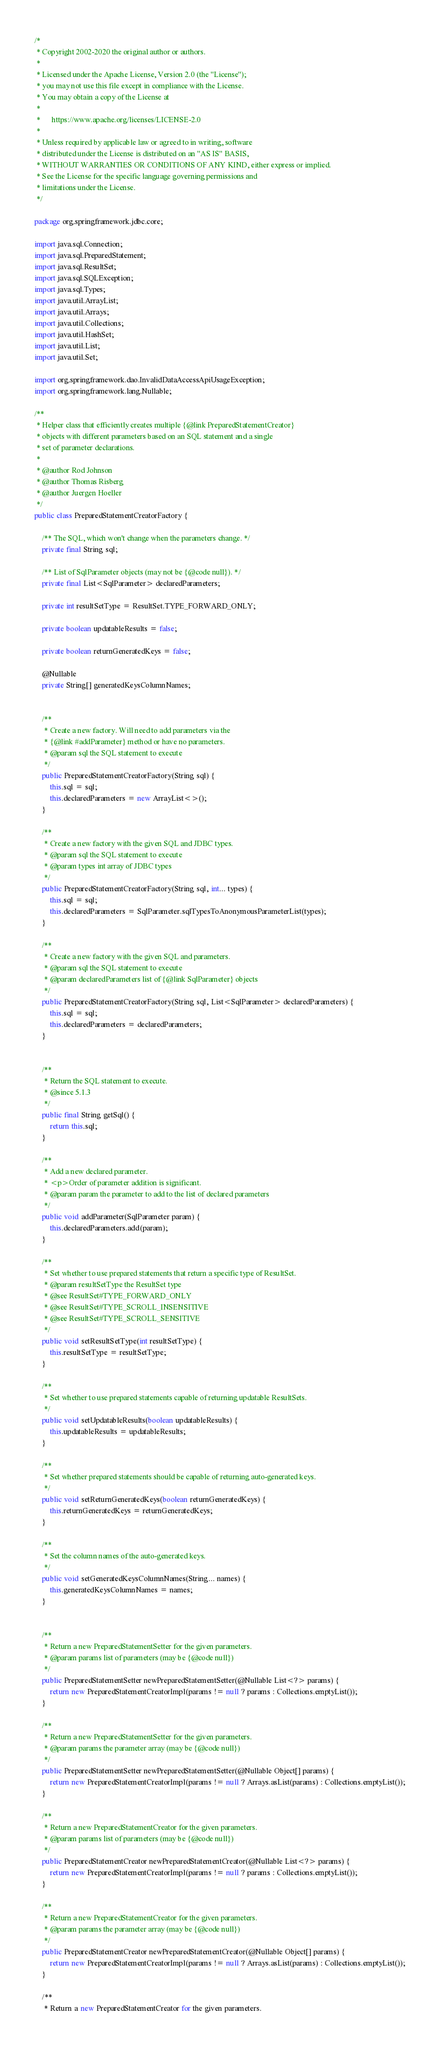Convert code to text. <code><loc_0><loc_0><loc_500><loc_500><_Java_>/*
 * Copyright 2002-2020 the original author or authors.
 *
 * Licensed under the Apache License, Version 2.0 (the "License");
 * you may not use this file except in compliance with the License.
 * You may obtain a copy of the License at
 *
 *      https://www.apache.org/licenses/LICENSE-2.0
 *
 * Unless required by applicable law or agreed to in writing, software
 * distributed under the License is distributed on an "AS IS" BASIS,
 * WITHOUT WARRANTIES OR CONDITIONS OF ANY KIND, either express or implied.
 * See the License for the specific language governing permissions and
 * limitations under the License.
 */

package org.springframework.jdbc.core;

import java.sql.Connection;
import java.sql.PreparedStatement;
import java.sql.ResultSet;
import java.sql.SQLException;
import java.sql.Types;
import java.util.ArrayList;
import java.util.Arrays;
import java.util.Collections;
import java.util.HashSet;
import java.util.List;
import java.util.Set;

import org.springframework.dao.InvalidDataAccessApiUsageException;
import org.springframework.lang.Nullable;

/**
 * Helper class that efficiently creates multiple {@link PreparedStatementCreator}
 * objects with different parameters based on an SQL statement and a single
 * set of parameter declarations.
 *
 * @author Rod Johnson
 * @author Thomas Risberg
 * @author Juergen Hoeller
 */
public class PreparedStatementCreatorFactory {

	/** The SQL, which won't change when the parameters change. */
	private final String sql;

	/** List of SqlParameter objects (may not be {@code null}). */
	private final List<SqlParameter> declaredParameters;

	private int resultSetType = ResultSet.TYPE_FORWARD_ONLY;

	private boolean updatableResults = false;

	private boolean returnGeneratedKeys = false;

	@Nullable
	private String[] generatedKeysColumnNames;


	/**
	 * Create a new factory. Will need to add parameters via the
	 * {@link #addParameter} method or have no parameters.
	 * @param sql the SQL statement to execute
	 */
	public PreparedStatementCreatorFactory(String sql) {
		this.sql = sql;
		this.declaredParameters = new ArrayList<>();
	}

	/**
	 * Create a new factory with the given SQL and JDBC types.
	 * @param sql the SQL statement to execute
	 * @param types int array of JDBC types
	 */
	public PreparedStatementCreatorFactory(String sql, int... types) {
		this.sql = sql;
		this.declaredParameters = SqlParameter.sqlTypesToAnonymousParameterList(types);
	}

	/**
	 * Create a new factory with the given SQL and parameters.
	 * @param sql the SQL statement to execute
	 * @param declaredParameters list of {@link SqlParameter} objects
	 */
	public PreparedStatementCreatorFactory(String sql, List<SqlParameter> declaredParameters) {
		this.sql = sql;
		this.declaredParameters = declaredParameters;
	}


	/**
	 * Return the SQL statement to execute.
	 * @since 5.1.3
	 */
	public final String getSql() {
		return this.sql;
	}

	/**
	 * Add a new declared parameter.
	 * <p>Order of parameter addition is significant.
	 * @param param the parameter to add to the list of declared parameters
	 */
	public void addParameter(SqlParameter param) {
		this.declaredParameters.add(param);
	}

	/**
	 * Set whether to use prepared statements that return a specific type of ResultSet.
	 * @param resultSetType the ResultSet type
	 * @see ResultSet#TYPE_FORWARD_ONLY
	 * @see ResultSet#TYPE_SCROLL_INSENSITIVE
	 * @see ResultSet#TYPE_SCROLL_SENSITIVE
	 */
	public void setResultSetType(int resultSetType) {
		this.resultSetType = resultSetType;
	}

	/**
	 * Set whether to use prepared statements capable of returning updatable ResultSets.
	 */
	public void setUpdatableResults(boolean updatableResults) {
		this.updatableResults = updatableResults;
	}

	/**
	 * Set whether prepared statements should be capable of returning auto-generated keys.
	 */
	public void setReturnGeneratedKeys(boolean returnGeneratedKeys) {
		this.returnGeneratedKeys = returnGeneratedKeys;
	}

	/**
	 * Set the column names of the auto-generated keys.
	 */
	public void setGeneratedKeysColumnNames(String... names) {
		this.generatedKeysColumnNames = names;
	}


	/**
	 * Return a new PreparedStatementSetter for the given parameters.
	 * @param params list of parameters (may be {@code null})
	 */
	public PreparedStatementSetter newPreparedStatementSetter(@Nullable List<?> params) {
		return new PreparedStatementCreatorImpl(params != null ? params : Collections.emptyList());
	}

	/**
	 * Return a new PreparedStatementSetter for the given parameters.
	 * @param params the parameter array (may be {@code null})
	 */
	public PreparedStatementSetter newPreparedStatementSetter(@Nullable Object[] params) {
		return new PreparedStatementCreatorImpl(params != null ? Arrays.asList(params) : Collections.emptyList());
	}

	/**
	 * Return a new PreparedStatementCreator for the given parameters.
	 * @param params list of parameters (may be {@code null})
	 */
	public PreparedStatementCreator newPreparedStatementCreator(@Nullable List<?> params) {
		return new PreparedStatementCreatorImpl(params != null ? params : Collections.emptyList());
	}

	/**
	 * Return a new PreparedStatementCreator for the given parameters.
	 * @param params the parameter array (may be {@code null})
	 */
	public PreparedStatementCreator newPreparedStatementCreator(@Nullable Object[] params) {
		return new PreparedStatementCreatorImpl(params != null ? Arrays.asList(params) : Collections.emptyList());
	}

	/**
	 * Return a new PreparedStatementCreator for the given parameters.</code> 